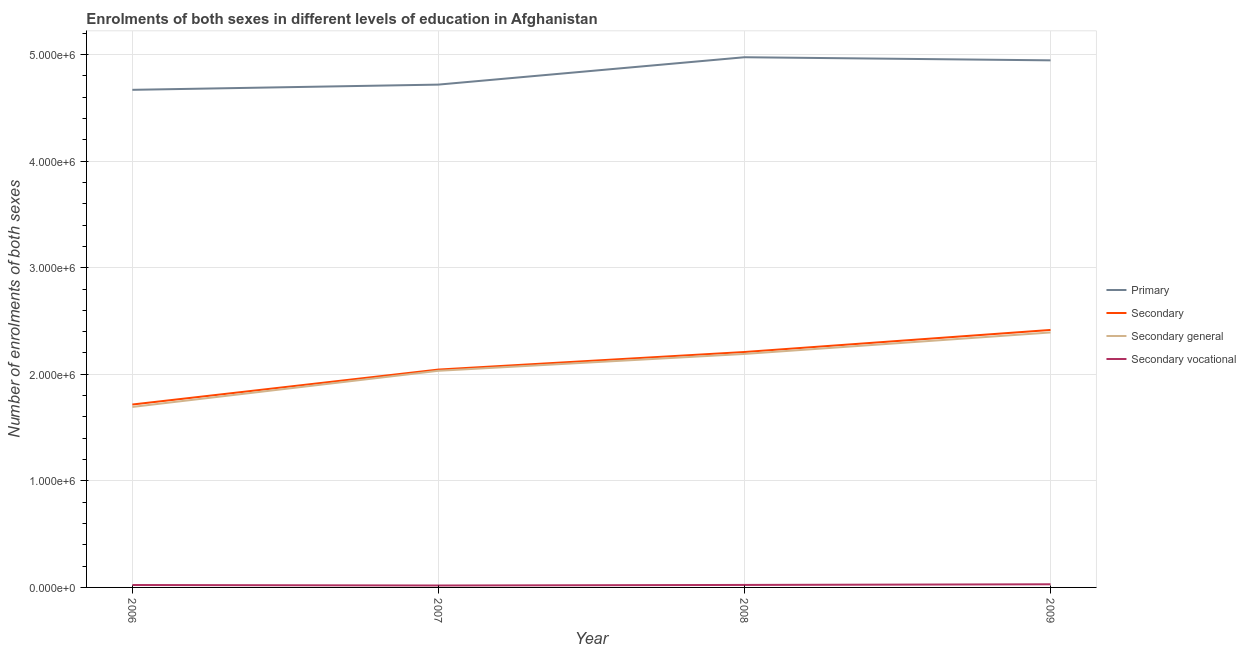How many different coloured lines are there?
Your response must be concise. 4. Is the number of lines equal to the number of legend labels?
Make the answer very short. Yes. What is the number of enrolments in secondary general education in 2009?
Give a very brief answer. 2.39e+06. Across all years, what is the maximum number of enrolments in secondary general education?
Offer a terse response. 2.39e+06. Across all years, what is the minimum number of enrolments in secondary vocational education?
Your answer should be compact. 1.81e+04. In which year was the number of enrolments in secondary education maximum?
Give a very brief answer. 2009. What is the total number of enrolments in secondary general education in the graph?
Your answer should be compact. 8.31e+06. What is the difference between the number of enrolments in secondary vocational education in 2008 and that in 2009?
Make the answer very short. -6101. What is the difference between the number of enrolments in secondary general education in 2007 and the number of enrolments in secondary vocational education in 2008?
Your response must be concise. 2.01e+06. What is the average number of enrolments in secondary vocational education per year?
Provide a succinct answer. 2.34e+04. In the year 2008, what is the difference between the number of enrolments in secondary general education and number of enrolments in secondary education?
Your answer should be compact. -1.81e+04. What is the ratio of the number of enrolments in secondary vocational education in 2007 to that in 2008?
Provide a succinct answer. 0.77. Is the number of enrolments in secondary vocational education in 2006 less than that in 2009?
Offer a terse response. Yes. Is the difference between the number of enrolments in secondary vocational education in 2006 and 2009 greater than the difference between the number of enrolments in secondary education in 2006 and 2009?
Make the answer very short. Yes. What is the difference between the highest and the second highest number of enrolments in primary education?
Offer a very short reply. 2.92e+04. What is the difference between the highest and the lowest number of enrolments in secondary education?
Provide a short and direct response. 7.00e+05. In how many years, is the number of enrolments in secondary education greater than the average number of enrolments in secondary education taken over all years?
Provide a succinct answer. 2. Is it the case that in every year, the sum of the number of enrolments in primary education and number of enrolments in secondary education is greater than the sum of number of enrolments in secondary general education and number of enrolments in secondary vocational education?
Offer a terse response. Yes. Is it the case that in every year, the sum of the number of enrolments in primary education and number of enrolments in secondary education is greater than the number of enrolments in secondary general education?
Your answer should be very brief. Yes. Does the number of enrolments in primary education monotonically increase over the years?
Keep it short and to the point. No. Is the number of enrolments in secondary education strictly greater than the number of enrolments in primary education over the years?
Keep it short and to the point. No. How many lines are there?
Ensure brevity in your answer.  4. How many years are there in the graph?
Keep it short and to the point. 4. What is the difference between two consecutive major ticks on the Y-axis?
Your answer should be very brief. 1.00e+06. Are the values on the major ticks of Y-axis written in scientific E-notation?
Your answer should be very brief. Yes. Does the graph contain any zero values?
Offer a terse response. No. Does the graph contain grids?
Your answer should be compact. Yes. How many legend labels are there?
Your answer should be very brief. 4. What is the title of the graph?
Provide a succinct answer. Enrolments of both sexes in different levels of education in Afghanistan. What is the label or title of the Y-axis?
Your answer should be compact. Number of enrolments of both sexes. What is the Number of enrolments of both sexes in Primary in 2006?
Your answer should be very brief. 4.67e+06. What is the Number of enrolments of both sexes of Secondary in 2006?
Offer a terse response. 1.72e+06. What is the Number of enrolments of both sexes of Secondary general in 2006?
Your answer should be very brief. 1.69e+06. What is the Number of enrolments of both sexes in Secondary vocational in 2006?
Make the answer very short. 2.27e+04. What is the Number of enrolments of both sexes in Primary in 2007?
Your response must be concise. 4.72e+06. What is the Number of enrolments of both sexes in Secondary in 2007?
Provide a short and direct response. 2.04e+06. What is the Number of enrolments of both sexes in Secondary general in 2007?
Ensure brevity in your answer.  2.03e+06. What is the Number of enrolments of both sexes of Secondary vocational in 2007?
Offer a terse response. 1.81e+04. What is the Number of enrolments of both sexes of Primary in 2008?
Offer a terse response. 4.97e+06. What is the Number of enrolments of both sexes of Secondary in 2008?
Offer a very short reply. 2.21e+06. What is the Number of enrolments of both sexes of Secondary general in 2008?
Offer a very short reply. 2.19e+06. What is the Number of enrolments of both sexes in Secondary vocational in 2008?
Your answer should be compact. 2.34e+04. What is the Number of enrolments of both sexes in Primary in 2009?
Your answer should be very brief. 4.95e+06. What is the Number of enrolments of both sexes of Secondary in 2009?
Ensure brevity in your answer.  2.42e+06. What is the Number of enrolments of both sexes of Secondary general in 2009?
Your answer should be very brief. 2.39e+06. What is the Number of enrolments of both sexes of Secondary vocational in 2009?
Your answer should be compact. 2.95e+04. Across all years, what is the maximum Number of enrolments of both sexes in Primary?
Your response must be concise. 4.97e+06. Across all years, what is the maximum Number of enrolments of both sexes of Secondary?
Your answer should be compact. 2.42e+06. Across all years, what is the maximum Number of enrolments of both sexes of Secondary general?
Offer a very short reply. 2.39e+06. Across all years, what is the maximum Number of enrolments of both sexes in Secondary vocational?
Keep it short and to the point. 2.95e+04. Across all years, what is the minimum Number of enrolments of both sexes of Primary?
Offer a very short reply. 4.67e+06. Across all years, what is the minimum Number of enrolments of both sexes in Secondary?
Keep it short and to the point. 1.72e+06. Across all years, what is the minimum Number of enrolments of both sexes in Secondary general?
Give a very brief answer. 1.69e+06. Across all years, what is the minimum Number of enrolments of both sexes in Secondary vocational?
Provide a short and direct response. 1.81e+04. What is the total Number of enrolments of both sexes of Primary in the graph?
Your answer should be compact. 1.93e+07. What is the total Number of enrolments of both sexes of Secondary in the graph?
Give a very brief answer. 8.39e+06. What is the total Number of enrolments of both sexes in Secondary general in the graph?
Offer a terse response. 8.31e+06. What is the total Number of enrolments of both sexes of Secondary vocational in the graph?
Your answer should be compact. 9.37e+04. What is the difference between the Number of enrolments of both sexes in Primary in 2006 and that in 2007?
Ensure brevity in your answer.  -4.90e+04. What is the difference between the Number of enrolments of both sexes in Secondary in 2006 and that in 2007?
Provide a short and direct response. -3.28e+05. What is the difference between the Number of enrolments of both sexes in Secondary general in 2006 and that in 2007?
Give a very brief answer. -3.39e+05. What is the difference between the Number of enrolments of both sexes in Secondary vocational in 2006 and that in 2007?
Provide a short and direct response. 4626. What is the difference between the Number of enrolments of both sexes of Primary in 2006 and that in 2008?
Provide a succinct answer. -3.06e+05. What is the difference between the Number of enrolments of both sexes of Secondary in 2006 and that in 2008?
Make the answer very short. -4.93e+05. What is the difference between the Number of enrolments of both sexes of Secondary general in 2006 and that in 2008?
Offer a very short reply. -4.97e+05. What is the difference between the Number of enrolments of both sexes of Secondary vocational in 2006 and that in 2008?
Your answer should be very brief. -708. What is the difference between the Number of enrolments of both sexes in Primary in 2006 and that in 2009?
Provide a short and direct response. -2.77e+05. What is the difference between the Number of enrolments of both sexes in Secondary in 2006 and that in 2009?
Give a very brief answer. -7.00e+05. What is the difference between the Number of enrolments of both sexes in Secondary general in 2006 and that in 2009?
Your answer should be very brief. -6.99e+05. What is the difference between the Number of enrolments of both sexes in Secondary vocational in 2006 and that in 2009?
Provide a short and direct response. -6809. What is the difference between the Number of enrolments of both sexes in Primary in 2007 and that in 2008?
Offer a very short reply. -2.57e+05. What is the difference between the Number of enrolments of both sexes of Secondary in 2007 and that in 2008?
Your response must be concise. -1.65e+05. What is the difference between the Number of enrolments of both sexes in Secondary general in 2007 and that in 2008?
Provide a succinct answer. -1.58e+05. What is the difference between the Number of enrolments of both sexes in Secondary vocational in 2007 and that in 2008?
Offer a very short reply. -5334. What is the difference between the Number of enrolments of both sexes of Primary in 2007 and that in 2009?
Give a very brief answer. -2.28e+05. What is the difference between the Number of enrolments of both sexes in Secondary in 2007 and that in 2009?
Your answer should be very brief. -3.72e+05. What is the difference between the Number of enrolments of both sexes of Secondary general in 2007 and that in 2009?
Give a very brief answer. -3.60e+05. What is the difference between the Number of enrolments of both sexes of Secondary vocational in 2007 and that in 2009?
Provide a short and direct response. -1.14e+04. What is the difference between the Number of enrolments of both sexes in Primary in 2008 and that in 2009?
Provide a succinct answer. 2.92e+04. What is the difference between the Number of enrolments of both sexes in Secondary in 2008 and that in 2009?
Offer a very short reply. -2.07e+05. What is the difference between the Number of enrolments of both sexes of Secondary general in 2008 and that in 2009?
Offer a terse response. -2.02e+05. What is the difference between the Number of enrolments of both sexes in Secondary vocational in 2008 and that in 2009?
Offer a very short reply. -6101. What is the difference between the Number of enrolments of both sexes in Primary in 2006 and the Number of enrolments of both sexes in Secondary in 2007?
Provide a short and direct response. 2.62e+06. What is the difference between the Number of enrolments of both sexes of Primary in 2006 and the Number of enrolments of both sexes of Secondary general in 2007?
Offer a terse response. 2.64e+06. What is the difference between the Number of enrolments of both sexes in Primary in 2006 and the Number of enrolments of both sexes in Secondary vocational in 2007?
Ensure brevity in your answer.  4.65e+06. What is the difference between the Number of enrolments of both sexes of Secondary in 2006 and the Number of enrolments of both sexes of Secondary general in 2007?
Your response must be concise. -3.17e+05. What is the difference between the Number of enrolments of both sexes of Secondary in 2006 and the Number of enrolments of both sexes of Secondary vocational in 2007?
Provide a succinct answer. 1.70e+06. What is the difference between the Number of enrolments of both sexes in Secondary general in 2006 and the Number of enrolments of both sexes in Secondary vocational in 2007?
Provide a short and direct response. 1.68e+06. What is the difference between the Number of enrolments of both sexes in Primary in 2006 and the Number of enrolments of both sexes in Secondary in 2008?
Ensure brevity in your answer.  2.46e+06. What is the difference between the Number of enrolments of both sexes in Primary in 2006 and the Number of enrolments of both sexes in Secondary general in 2008?
Keep it short and to the point. 2.48e+06. What is the difference between the Number of enrolments of both sexes of Primary in 2006 and the Number of enrolments of both sexes of Secondary vocational in 2008?
Offer a very short reply. 4.65e+06. What is the difference between the Number of enrolments of both sexes of Secondary in 2006 and the Number of enrolments of both sexes of Secondary general in 2008?
Make the answer very short. -4.75e+05. What is the difference between the Number of enrolments of both sexes of Secondary in 2006 and the Number of enrolments of both sexes of Secondary vocational in 2008?
Make the answer very short. 1.69e+06. What is the difference between the Number of enrolments of both sexes of Secondary general in 2006 and the Number of enrolments of both sexes of Secondary vocational in 2008?
Ensure brevity in your answer.  1.67e+06. What is the difference between the Number of enrolments of both sexes in Primary in 2006 and the Number of enrolments of both sexes in Secondary in 2009?
Keep it short and to the point. 2.25e+06. What is the difference between the Number of enrolments of both sexes in Primary in 2006 and the Number of enrolments of both sexes in Secondary general in 2009?
Give a very brief answer. 2.28e+06. What is the difference between the Number of enrolments of both sexes in Primary in 2006 and the Number of enrolments of both sexes in Secondary vocational in 2009?
Your answer should be very brief. 4.64e+06. What is the difference between the Number of enrolments of both sexes of Secondary in 2006 and the Number of enrolments of both sexes of Secondary general in 2009?
Offer a terse response. -6.76e+05. What is the difference between the Number of enrolments of both sexes in Secondary in 2006 and the Number of enrolments of both sexes in Secondary vocational in 2009?
Give a very brief answer. 1.69e+06. What is the difference between the Number of enrolments of both sexes in Secondary general in 2006 and the Number of enrolments of both sexes in Secondary vocational in 2009?
Give a very brief answer. 1.66e+06. What is the difference between the Number of enrolments of both sexes in Primary in 2007 and the Number of enrolments of both sexes in Secondary in 2008?
Provide a succinct answer. 2.51e+06. What is the difference between the Number of enrolments of both sexes of Primary in 2007 and the Number of enrolments of both sexes of Secondary general in 2008?
Make the answer very short. 2.53e+06. What is the difference between the Number of enrolments of both sexes of Primary in 2007 and the Number of enrolments of both sexes of Secondary vocational in 2008?
Offer a terse response. 4.69e+06. What is the difference between the Number of enrolments of both sexes of Secondary in 2007 and the Number of enrolments of both sexes of Secondary general in 2008?
Offer a terse response. -1.47e+05. What is the difference between the Number of enrolments of both sexes in Secondary in 2007 and the Number of enrolments of both sexes in Secondary vocational in 2008?
Provide a short and direct response. 2.02e+06. What is the difference between the Number of enrolments of both sexes in Secondary general in 2007 and the Number of enrolments of both sexes in Secondary vocational in 2008?
Provide a succinct answer. 2.01e+06. What is the difference between the Number of enrolments of both sexes in Primary in 2007 and the Number of enrolments of both sexes in Secondary in 2009?
Give a very brief answer. 2.30e+06. What is the difference between the Number of enrolments of both sexes of Primary in 2007 and the Number of enrolments of both sexes of Secondary general in 2009?
Give a very brief answer. 2.33e+06. What is the difference between the Number of enrolments of both sexes in Primary in 2007 and the Number of enrolments of both sexes in Secondary vocational in 2009?
Provide a succinct answer. 4.69e+06. What is the difference between the Number of enrolments of both sexes of Secondary in 2007 and the Number of enrolments of both sexes of Secondary general in 2009?
Your answer should be very brief. -3.48e+05. What is the difference between the Number of enrolments of both sexes in Secondary in 2007 and the Number of enrolments of both sexes in Secondary vocational in 2009?
Offer a terse response. 2.01e+06. What is the difference between the Number of enrolments of both sexes in Secondary general in 2007 and the Number of enrolments of both sexes in Secondary vocational in 2009?
Your response must be concise. 2.00e+06. What is the difference between the Number of enrolments of both sexes in Primary in 2008 and the Number of enrolments of both sexes in Secondary in 2009?
Offer a terse response. 2.56e+06. What is the difference between the Number of enrolments of both sexes in Primary in 2008 and the Number of enrolments of both sexes in Secondary general in 2009?
Give a very brief answer. 2.58e+06. What is the difference between the Number of enrolments of both sexes in Primary in 2008 and the Number of enrolments of both sexes in Secondary vocational in 2009?
Your answer should be very brief. 4.95e+06. What is the difference between the Number of enrolments of both sexes of Secondary in 2008 and the Number of enrolments of both sexes of Secondary general in 2009?
Provide a succinct answer. -1.84e+05. What is the difference between the Number of enrolments of both sexes in Secondary in 2008 and the Number of enrolments of both sexes in Secondary vocational in 2009?
Keep it short and to the point. 2.18e+06. What is the difference between the Number of enrolments of both sexes in Secondary general in 2008 and the Number of enrolments of both sexes in Secondary vocational in 2009?
Your response must be concise. 2.16e+06. What is the average Number of enrolments of both sexes in Primary per year?
Your answer should be very brief. 4.83e+06. What is the average Number of enrolments of both sexes in Secondary per year?
Keep it short and to the point. 2.10e+06. What is the average Number of enrolments of both sexes in Secondary general per year?
Your response must be concise. 2.08e+06. What is the average Number of enrolments of both sexes in Secondary vocational per year?
Give a very brief answer. 2.34e+04. In the year 2006, what is the difference between the Number of enrolments of both sexes of Primary and Number of enrolments of both sexes of Secondary?
Your answer should be very brief. 2.95e+06. In the year 2006, what is the difference between the Number of enrolments of both sexes in Primary and Number of enrolments of both sexes in Secondary general?
Keep it short and to the point. 2.98e+06. In the year 2006, what is the difference between the Number of enrolments of both sexes in Primary and Number of enrolments of both sexes in Secondary vocational?
Your answer should be very brief. 4.65e+06. In the year 2006, what is the difference between the Number of enrolments of both sexes in Secondary and Number of enrolments of both sexes in Secondary general?
Ensure brevity in your answer.  2.27e+04. In the year 2006, what is the difference between the Number of enrolments of both sexes of Secondary and Number of enrolments of both sexes of Secondary vocational?
Your answer should be compact. 1.69e+06. In the year 2006, what is the difference between the Number of enrolments of both sexes in Secondary general and Number of enrolments of both sexes in Secondary vocational?
Your answer should be very brief. 1.67e+06. In the year 2007, what is the difference between the Number of enrolments of both sexes of Primary and Number of enrolments of both sexes of Secondary?
Keep it short and to the point. 2.67e+06. In the year 2007, what is the difference between the Number of enrolments of both sexes in Primary and Number of enrolments of both sexes in Secondary general?
Your answer should be very brief. 2.69e+06. In the year 2007, what is the difference between the Number of enrolments of both sexes of Primary and Number of enrolments of both sexes of Secondary vocational?
Your answer should be very brief. 4.70e+06. In the year 2007, what is the difference between the Number of enrolments of both sexes of Secondary and Number of enrolments of both sexes of Secondary general?
Make the answer very short. 1.14e+04. In the year 2007, what is the difference between the Number of enrolments of both sexes in Secondary and Number of enrolments of both sexes in Secondary vocational?
Your answer should be very brief. 2.03e+06. In the year 2007, what is the difference between the Number of enrolments of both sexes in Secondary general and Number of enrolments of both sexes in Secondary vocational?
Your answer should be compact. 2.01e+06. In the year 2008, what is the difference between the Number of enrolments of both sexes in Primary and Number of enrolments of both sexes in Secondary?
Make the answer very short. 2.77e+06. In the year 2008, what is the difference between the Number of enrolments of both sexes of Primary and Number of enrolments of both sexes of Secondary general?
Make the answer very short. 2.78e+06. In the year 2008, what is the difference between the Number of enrolments of both sexes in Primary and Number of enrolments of both sexes in Secondary vocational?
Your answer should be compact. 4.95e+06. In the year 2008, what is the difference between the Number of enrolments of both sexes in Secondary and Number of enrolments of both sexes in Secondary general?
Make the answer very short. 1.81e+04. In the year 2008, what is the difference between the Number of enrolments of both sexes in Secondary and Number of enrolments of both sexes in Secondary vocational?
Your response must be concise. 2.19e+06. In the year 2008, what is the difference between the Number of enrolments of both sexes in Secondary general and Number of enrolments of both sexes in Secondary vocational?
Provide a short and direct response. 2.17e+06. In the year 2009, what is the difference between the Number of enrolments of both sexes of Primary and Number of enrolments of both sexes of Secondary?
Your response must be concise. 2.53e+06. In the year 2009, what is the difference between the Number of enrolments of both sexes in Primary and Number of enrolments of both sexes in Secondary general?
Provide a short and direct response. 2.55e+06. In the year 2009, what is the difference between the Number of enrolments of both sexes in Primary and Number of enrolments of both sexes in Secondary vocational?
Provide a succinct answer. 4.92e+06. In the year 2009, what is the difference between the Number of enrolments of both sexes in Secondary and Number of enrolments of both sexes in Secondary general?
Your answer should be compact. 2.34e+04. In the year 2009, what is the difference between the Number of enrolments of both sexes of Secondary and Number of enrolments of both sexes of Secondary vocational?
Ensure brevity in your answer.  2.39e+06. In the year 2009, what is the difference between the Number of enrolments of both sexes in Secondary general and Number of enrolments of both sexes in Secondary vocational?
Offer a terse response. 2.36e+06. What is the ratio of the Number of enrolments of both sexes in Secondary in 2006 to that in 2007?
Offer a terse response. 0.84. What is the ratio of the Number of enrolments of both sexes in Secondary general in 2006 to that in 2007?
Ensure brevity in your answer.  0.83. What is the ratio of the Number of enrolments of both sexes of Secondary vocational in 2006 to that in 2007?
Make the answer very short. 1.26. What is the ratio of the Number of enrolments of both sexes in Primary in 2006 to that in 2008?
Offer a terse response. 0.94. What is the ratio of the Number of enrolments of both sexes of Secondary in 2006 to that in 2008?
Your answer should be compact. 0.78. What is the ratio of the Number of enrolments of both sexes of Secondary general in 2006 to that in 2008?
Your answer should be compact. 0.77. What is the ratio of the Number of enrolments of both sexes in Secondary vocational in 2006 to that in 2008?
Give a very brief answer. 0.97. What is the ratio of the Number of enrolments of both sexes of Primary in 2006 to that in 2009?
Provide a succinct answer. 0.94. What is the ratio of the Number of enrolments of both sexes of Secondary in 2006 to that in 2009?
Provide a succinct answer. 0.71. What is the ratio of the Number of enrolments of both sexes in Secondary general in 2006 to that in 2009?
Offer a terse response. 0.71. What is the ratio of the Number of enrolments of both sexes of Secondary vocational in 2006 to that in 2009?
Make the answer very short. 0.77. What is the ratio of the Number of enrolments of both sexes of Primary in 2007 to that in 2008?
Make the answer very short. 0.95. What is the ratio of the Number of enrolments of both sexes in Secondary in 2007 to that in 2008?
Your answer should be compact. 0.93. What is the ratio of the Number of enrolments of both sexes of Secondary general in 2007 to that in 2008?
Give a very brief answer. 0.93. What is the ratio of the Number of enrolments of both sexes in Secondary vocational in 2007 to that in 2008?
Provide a short and direct response. 0.77. What is the ratio of the Number of enrolments of both sexes of Primary in 2007 to that in 2009?
Provide a succinct answer. 0.95. What is the ratio of the Number of enrolments of both sexes in Secondary in 2007 to that in 2009?
Your response must be concise. 0.85. What is the ratio of the Number of enrolments of both sexes in Secondary general in 2007 to that in 2009?
Make the answer very short. 0.85. What is the ratio of the Number of enrolments of both sexes in Secondary vocational in 2007 to that in 2009?
Your answer should be compact. 0.61. What is the ratio of the Number of enrolments of both sexes of Primary in 2008 to that in 2009?
Give a very brief answer. 1.01. What is the ratio of the Number of enrolments of both sexes in Secondary in 2008 to that in 2009?
Offer a very short reply. 0.91. What is the ratio of the Number of enrolments of both sexes in Secondary general in 2008 to that in 2009?
Your answer should be very brief. 0.92. What is the ratio of the Number of enrolments of both sexes of Secondary vocational in 2008 to that in 2009?
Keep it short and to the point. 0.79. What is the difference between the highest and the second highest Number of enrolments of both sexes in Primary?
Give a very brief answer. 2.92e+04. What is the difference between the highest and the second highest Number of enrolments of both sexes of Secondary?
Offer a terse response. 2.07e+05. What is the difference between the highest and the second highest Number of enrolments of both sexes of Secondary general?
Make the answer very short. 2.02e+05. What is the difference between the highest and the second highest Number of enrolments of both sexes in Secondary vocational?
Provide a succinct answer. 6101. What is the difference between the highest and the lowest Number of enrolments of both sexes in Primary?
Give a very brief answer. 3.06e+05. What is the difference between the highest and the lowest Number of enrolments of both sexes in Secondary?
Give a very brief answer. 7.00e+05. What is the difference between the highest and the lowest Number of enrolments of both sexes of Secondary general?
Provide a short and direct response. 6.99e+05. What is the difference between the highest and the lowest Number of enrolments of both sexes in Secondary vocational?
Offer a terse response. 1.14e+04. 